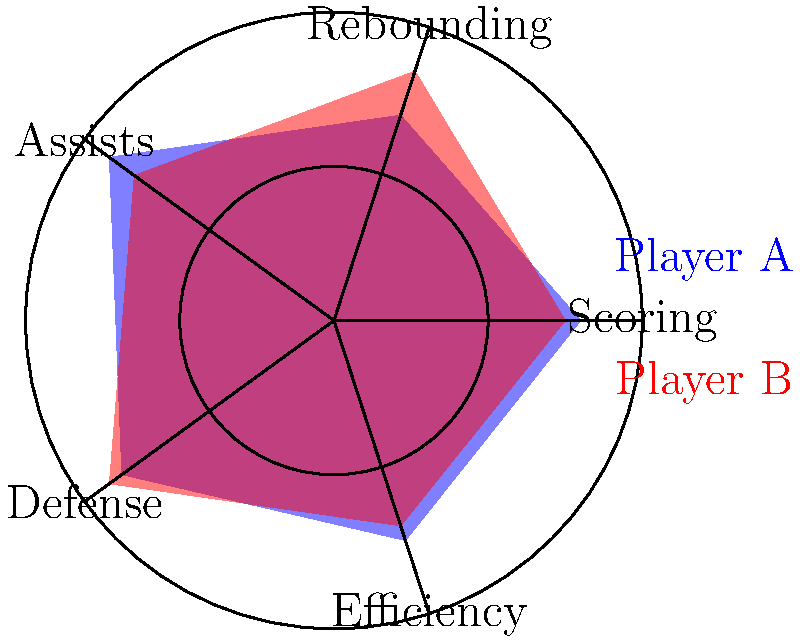As a data scientist analyzing your child's basketball team, you've created radar charts to compare two players' efficiency ratings across five categories: Scoring, Rebounding, Assists, Defense, and Efficiency. Based on the radar chart, which player has a higher overall efficiency rating, and what specific skill should Player A focus on improving to enhance their overall performance? To answer this question, we need to analyze the radar chart and compare the two players' performance across all categories:

1. Scoring:
   Player A: 80
   Player B: 75
   Player A is better

2. Rebounding:
   Player A: 70
   Player B: 85
   Player B is better

3. Assists:
   Player A: 90
   Player B: 80
   Player A is better

4. Defense:
   Player A: 85
   Player B: 90
   Player B is better

5. Efficiency:
   Player A: 75
   Player B: 70
   Player A is better

To determine the overall efficiency rating, we can calculate the average score across all categories:

Player A: $(80 + 70 + 90 + 85 + 75) / 5 = 80$
Player B: $(75 + 85 + 80 + 90 + 70) / 5 = 80$

Both players have the same overall efficiency rating of 80.

To identify which skill Player A should focus on improving, we need to find the category with the lowest score:

Player A's lowest score is in the Rebounding category (70).

Therefore, Player A should focus on improving their rebounding skills to enhance their overall performance.
Answer: Both players have equal overall efficiency; Player A should focus on improving rebounding. 